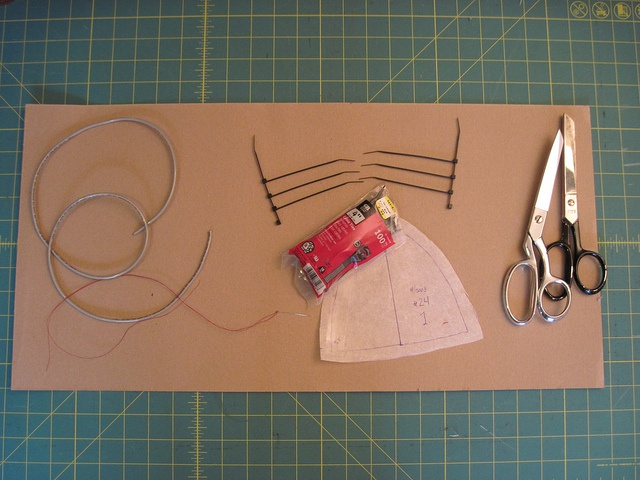Describe the objects in this image and their specific colors. I can see scissors in black, white, gray, tan, and brown tones and scissors in black, gray, tan, and ivory tones in this image. 